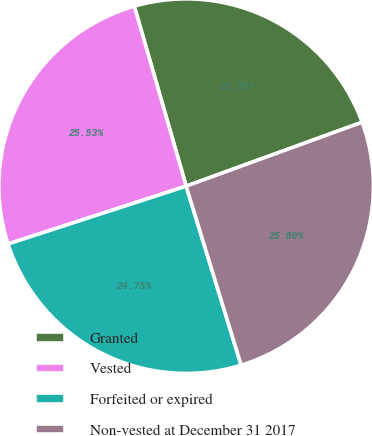<chart> <loc_0><loc_0><loc_500><loc_500><pie_chart><fcel>Granted<fcel>Vested<fcel>Forfeited or expired<fcel>Non-vested at December 31 2017<nl><fcel>23.92%<fcel>25.53%<fcel>24.75%<fcel>25.8%<nl></chart> 